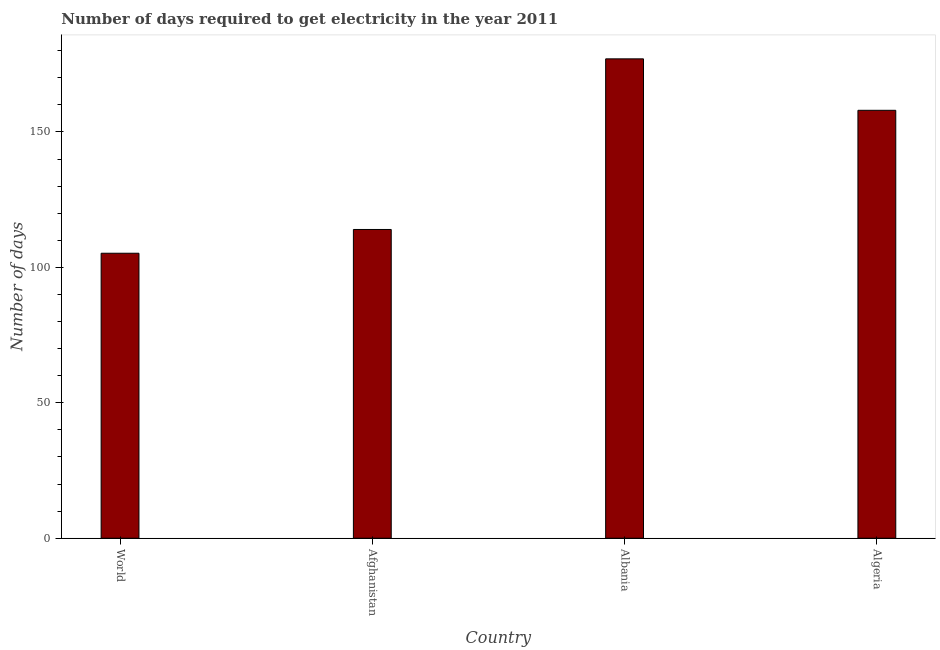Does the graph contain any zero values?
Offer a terse response. No. What is the title of the graph?
Ensure brevity in your answer.  Number of days required to get electricity in the year 2011. What is the label or title of the X-axis?
Offer a very short reply. Country. What is the label or title of the Y-axis?
Give a very brief answer. Number of days. What is the time to get electricity in World?
Your response must be concise. 105.22. Across all countries, what is the maximum time to get electricity?
Provide a short and direct response. 177. Across all countries, what is the minimum time to get electricity?
Ensure brevity in your answer.  105.22. In which country was the time to get electricity maximum?
Provide a short and direct response. Albania. What is the sum of the time to get electricity?
Make the answer very short. 554.22. What is the difference between the time to get electricity in Afghanistan and Albania?
Provide a succinct answer. -63. What is the average time to get electricity per country?
Offer a very short reply. 138.56. What is the median time to get electricity?
Provide a short and direct response. 136. What is the ratio of the time to get electricity in Afghanistan to that in Albania?
Your answer should be very brief. 0.64. What is the difference between the highest and the second highest time to get electricity?
Offer a terse response. 19. What is the difference between the highest and the lowest time to get electricity?
Offer a terse response. 71.78. Are all the bars in the graph horizontal?
Give a very brief answer. No. What is the difference between two consecutive major ticks on the Y-axis?
Give a very brief answer. 50. Are the values on the major ticks of Y-axis written in scientific E-notation?
Provide a succinct answer. No. What is the Number of days in World?
Ensure brevity in your answer.  105.22. What is the Number of days in Afghanistan?
Make the answer very short. 114. What is the Number of days of Albania?
Keep it short and to the point. 177. What is the Number of days in Algeria?
Keep it short and to the point. 158. What is the difference between the Number of days in World and Afghanistan?
Offer a very short reply. -8.78. What is the difference between the Number of days in World and Albania?
Your answer should be very brief. -71.78. What is the difference between the Number of days in World and Algeria?
Your answer should be compact. -52.78. What is the difference between the Number of days in Afghanistan and Albania?
Your response must be concise. -63. What is the difference between the Number of days in Afghanistan and Algeria?
Offer a terse response. -44. What is the ratio of the Number of days in World to that in Afghanistan?
Ensure brevity in your answer.  0.92. What is the ratio of the Number of days in World to that in Albania?
Your answer should be very brief. 0.59. What is the ratio of the Number of days in World to that in Algeria?
Ensure brevity in your answer.  0.67. What is the ratio of the Number of days in Afghanistan to that in Albania?
Provide a short and direct response. 0.64. What is the ratio of the Number of days in Afghanistan to that in Algeria?
Provide a short and direct response. 0.72. What is the ratio of the Number of days in Albania to that in Algeria?
Your answer should be very brief. 1.12. 